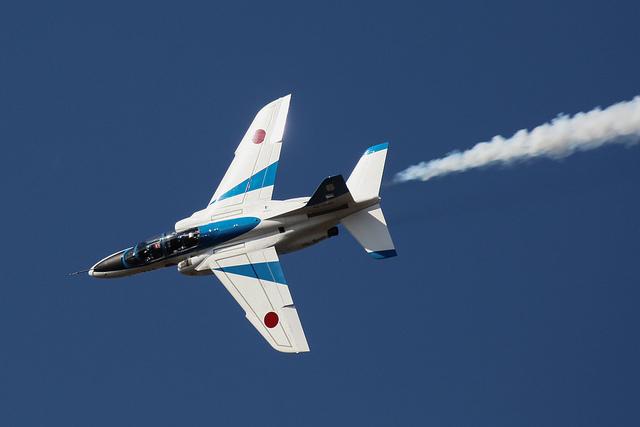What colors are on the plane?
Be succinct. Blue and white. What type of vehicle is this?
Give a very brief answer. Plane. How many people are in the train?
Be succinct. 0. 